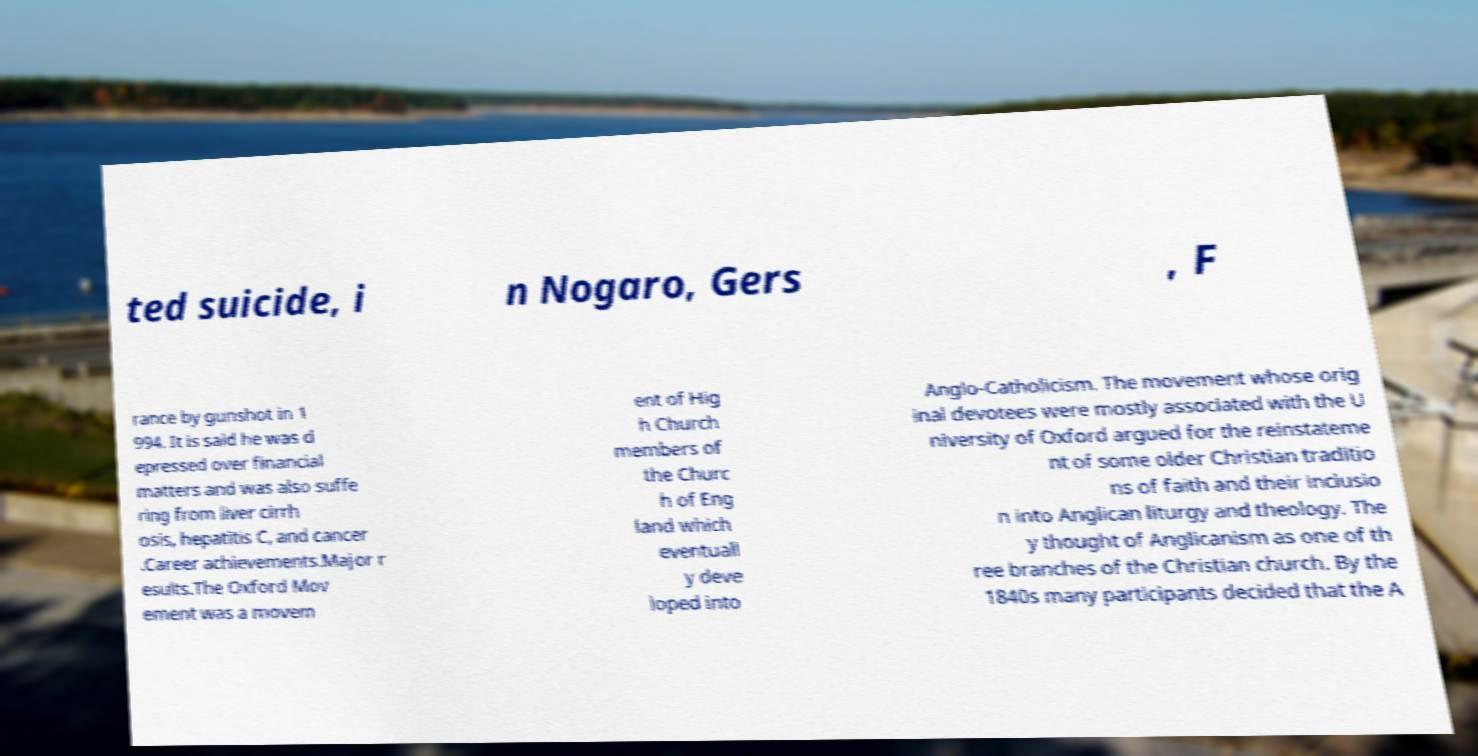Please identify and transcribe the text found in this image. ted suicide, i n Nogaro, Gers , F rance by gunshot in 1 994. It is said he was d epressed over financial matters and was also suffe ring from liver cirrh osis, hepatitis C, and cancer .Career achievements.Major r esults.The Oxford Mov ement was a movem ent of Hig h Church members of the Churc h of Eng land which eventuall y deve loped into Anglo-Catholicism. The movement whose orig inal devotees were mostly associated with the U niversity of Oxford argued for the reinstateme nt of some older Christian traditio ns of faith and their inclusio n into Anglican liturgy and theology. The y thought of Anglicanism as one of th ree branches of the Christian church. By the 1840s many participants decided that the A 